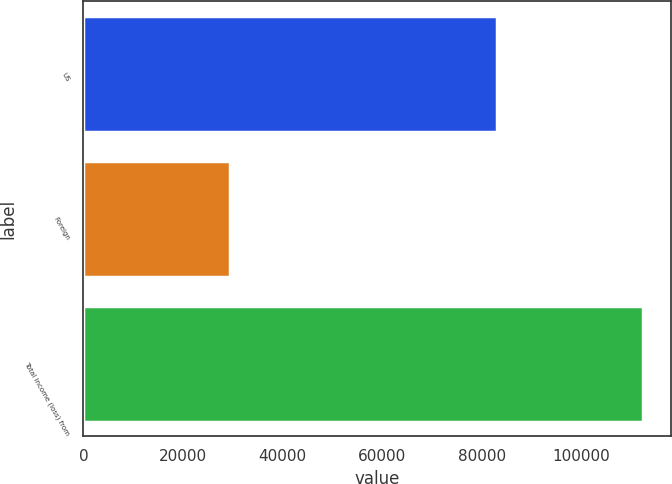Convert chart to OTSL. <chart><loc_0><loc_0><loc_500><loc_500><bar_chart><fcel>US<fcel>Foreign<fcel>Total income (loss) from<nl><fcel>82970<fcel>29437<fcel>112407<nl></chart> 